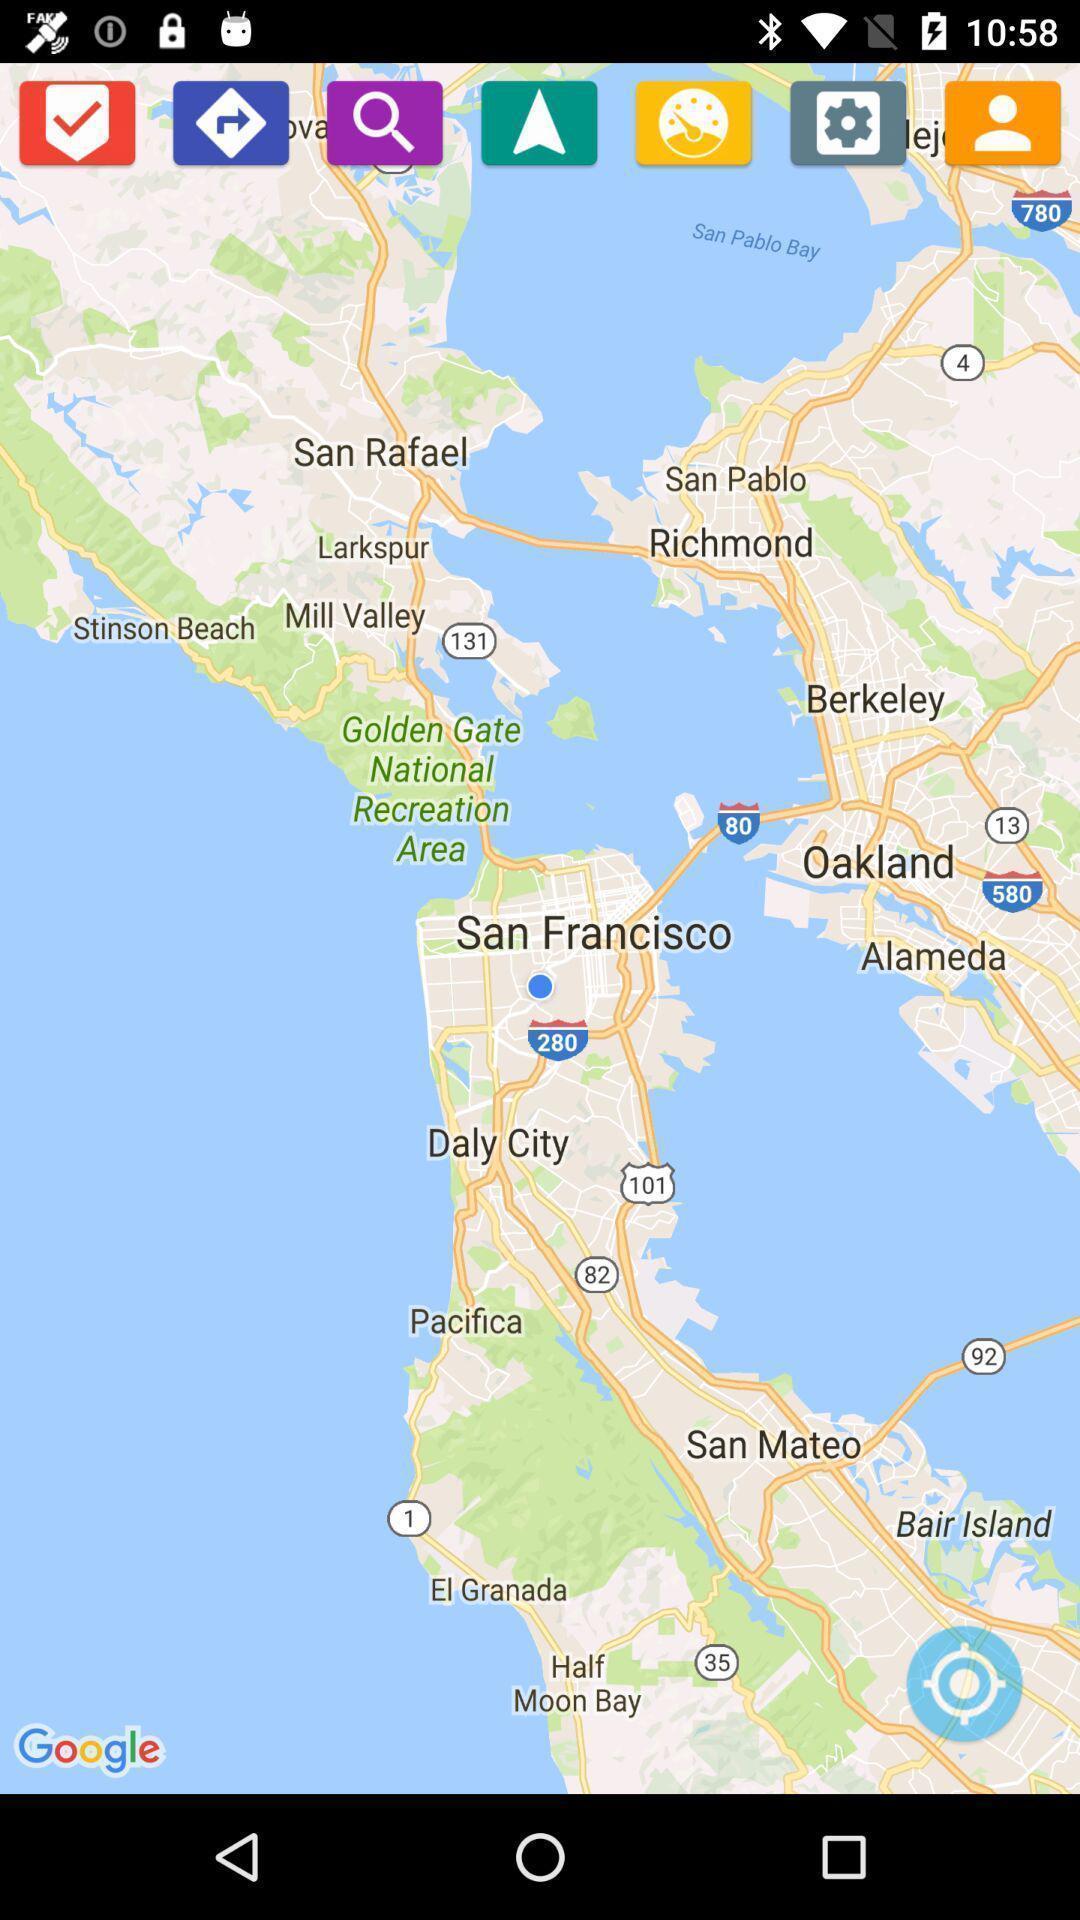Describe the content in this image. Screen shows a local map of a country. 